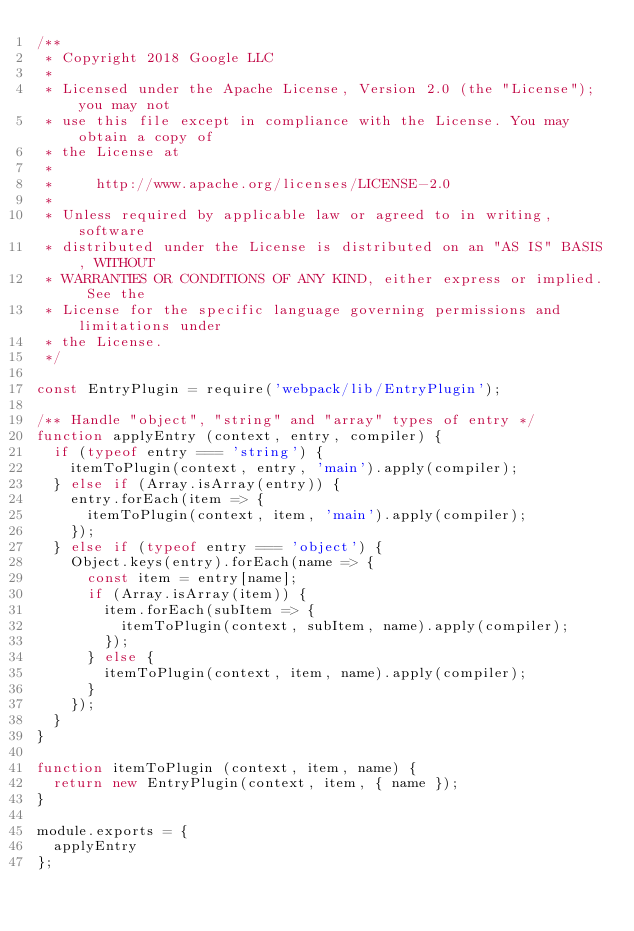Convert code to text. <code><loc_0><loc_0><loc_500><loc_500><_JavaScript_>/**
 * Copyright 2018 Google LLC
 *
 * Licensed under the Apache License, Version 2.0 (the "License"); you may not
 * use this file except in compliance with the License. You may obtain a copy of
 * the License at
 *
 *     http://www.apache.org/licenses/LICENSE-2.0
 *
 * Unless required by applicable law or agreed to in writing, software
 * distributed under the License is distributed on an "AS IS" BASIS, WITHOUT
 * WARRANTIES OR CONDITIONS OF ANY KIND, either express or implied. See the
 * License for the specific language governing permissions and limitations under
 * the License.
 */

const EntryPlugin = require('webpack/lib/EntryPlugin');

/** Handle "object", "string" and "array" types of entry */
function applyEntry (context, entry, compiler) {
  if (typeof entry === 'string') {
    itemToPlugin(context, entry, 'main').apply(compiler);
  } else if (Array.isArray(entry)) {
    entry.forEach(item => {
      itemToPlugin(context, item, 'main').apply(compiler);
    });
  } else if (typeof entry === 'object') {
    Object.keys(entry).forEach(name => {
      const item = entry[name];
      if (Array.isArray(item)) {
        item.forEach(subItem => {
          itemToPlugin(context, subItem, name).apply(compiler);
        });
      } else {
        itemToPlugin(context, item, name).apply(compiler);
      }
    });
  }
}

function itemToPlugin (context, item, name) {
  return new EntryPlugin(context, item, { name });
}

module.exports = {
  applyEntry
};
</code> 